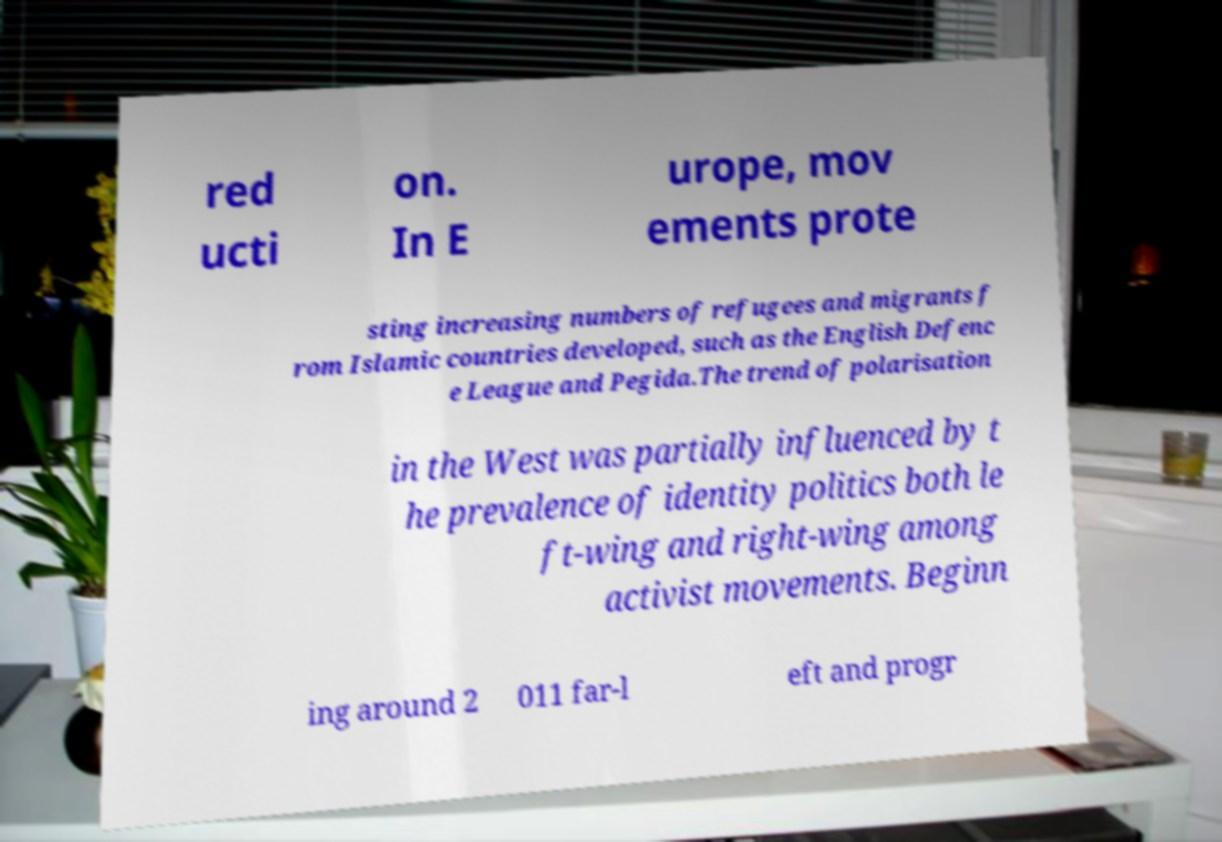Can you read and provide the text displayed in the image?This photo seems to have some interesting text. Can you extract and type it out for me? red ucti on. In E urope, mov ements prote sting increasing numbers of refugees and migrants f rom Islamic countries developed, such as the English Defenc e League and Pegida.The trend of polarisation in the West was partially influenced by t he prevalence of identity politics both le ft-wing and right-wing among activist movements. Beginn ing around 2 011 far-l eft and progr 